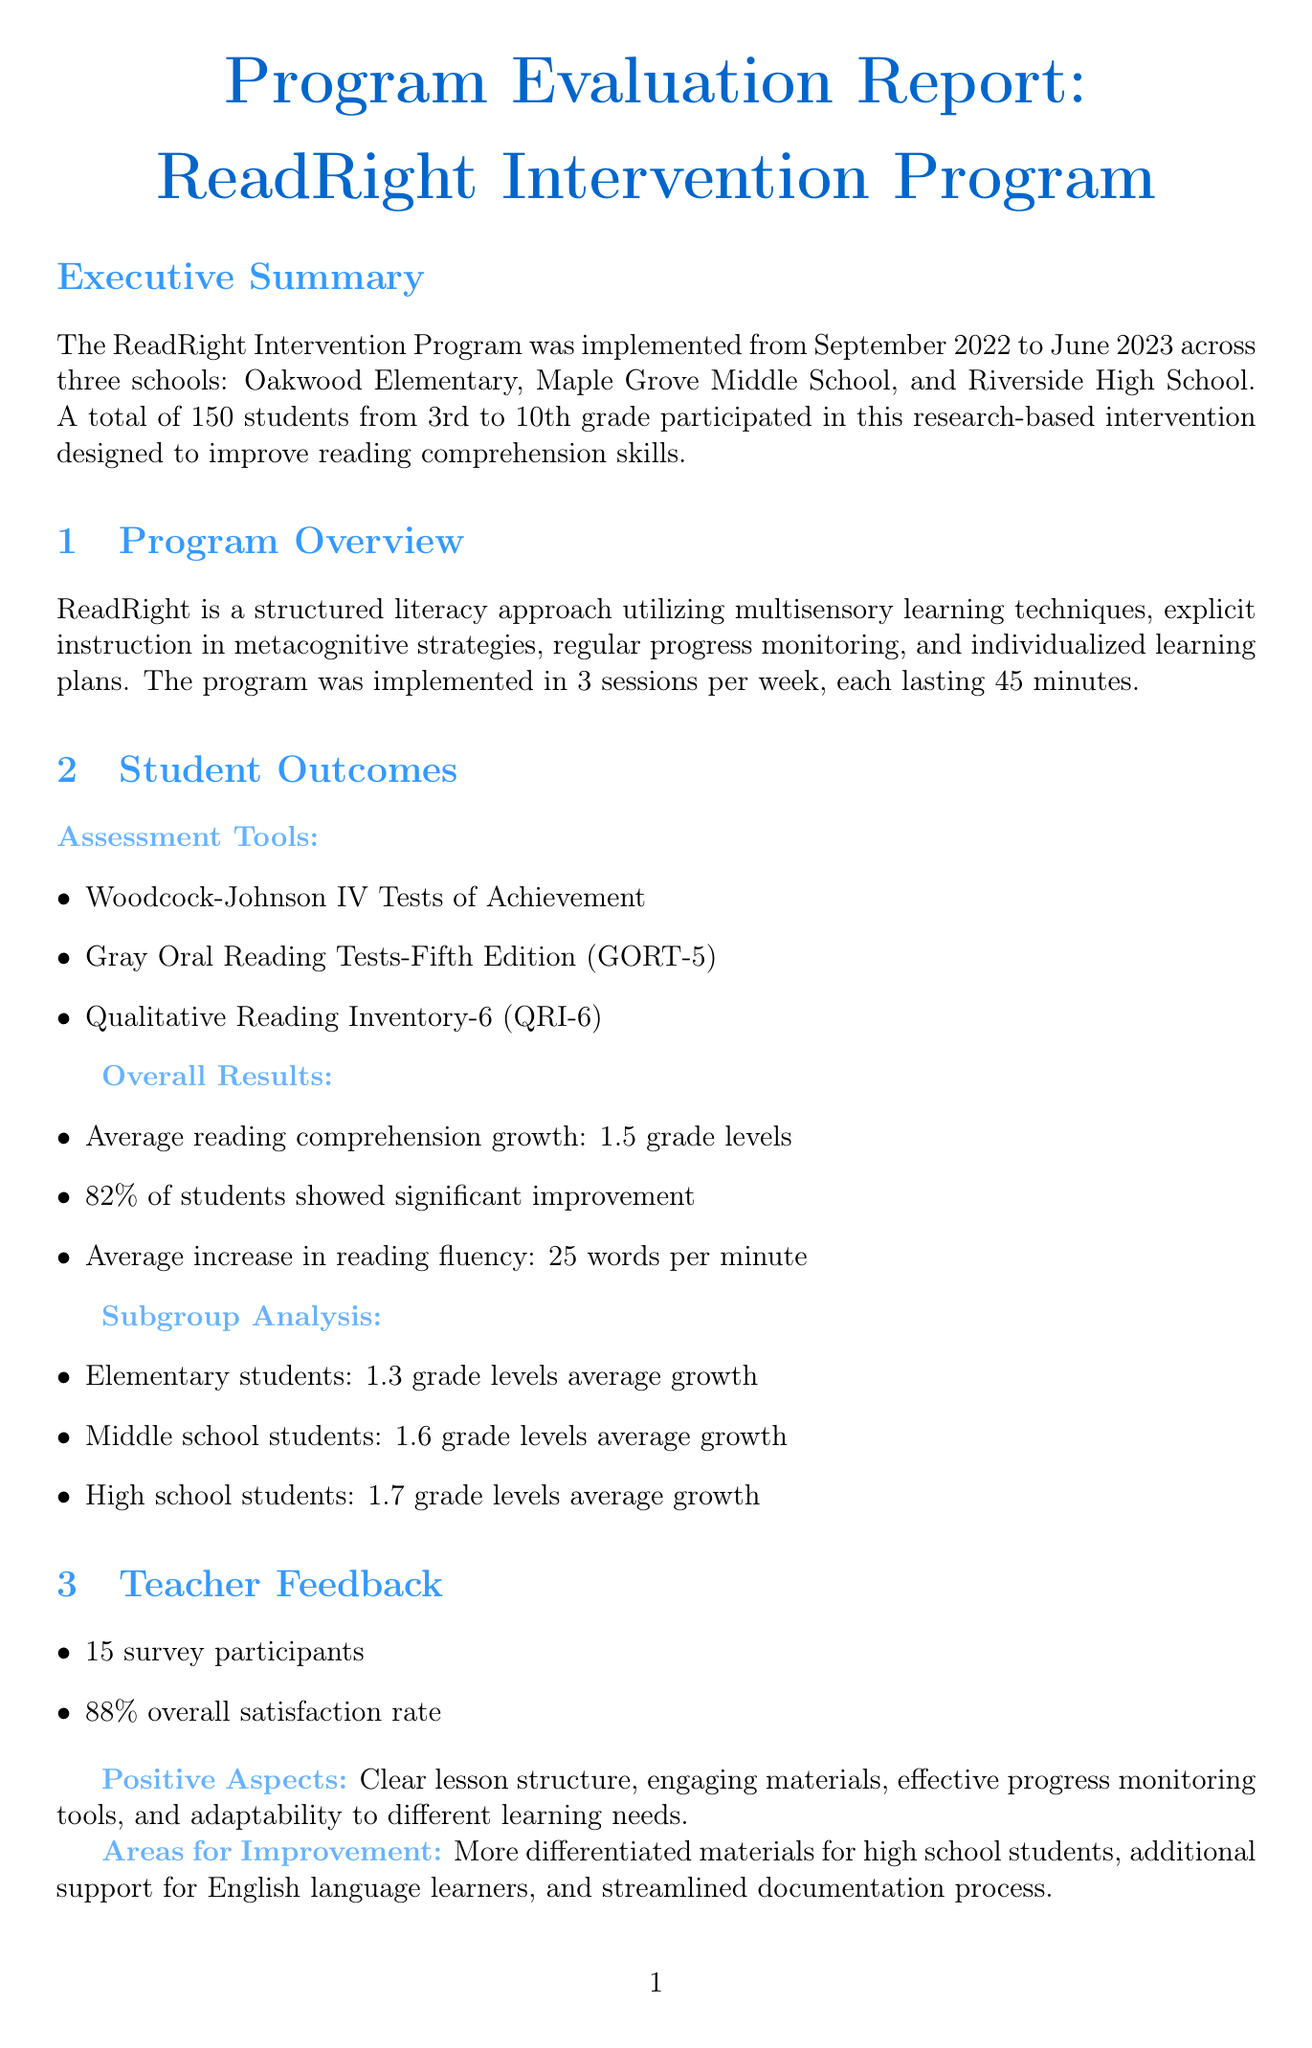What is the program name? The program name is indicated in the executive summary section of the document.
Answer: ReadRight Intervention Program What is the average reading comprehension growth for middle school students? This information is found in the subgroup analysis of student outcomes.
Answer: 1.6 grade levels What percentage of students showed significant improvement? This percentage is provided in the overall results section under student outcomes.
Answer: 82% How many schools participated in the program? The number of participating schools is detailed in the executive summary.
Answer: 3 What is the overall satisfaction rate from teacher feedback? The satisfaction rate is mentioned in the teacher feedback section of the report.
Answer: 88% What was the cost per student for the ReadRight program? The cost per student can be found in the cost-effectiveness analysis.
Answer: $200 per year Which assessment tool measures reading fluency? This is part of the assessment tools section listed under student outcomes.
Answer: Gray Oral Reading Tests-Fifth Edition (GORT-5) What is one area for improvement noted by teachers? Areas for improvement are collected in the teacher feedback section.
Answer: More differentiated materials for high school students What are the proposed actions for the next steps? The proposed actions are outlined in the conclusion and next steps section of the document.
Answer: Expand program to additional schools in the district 